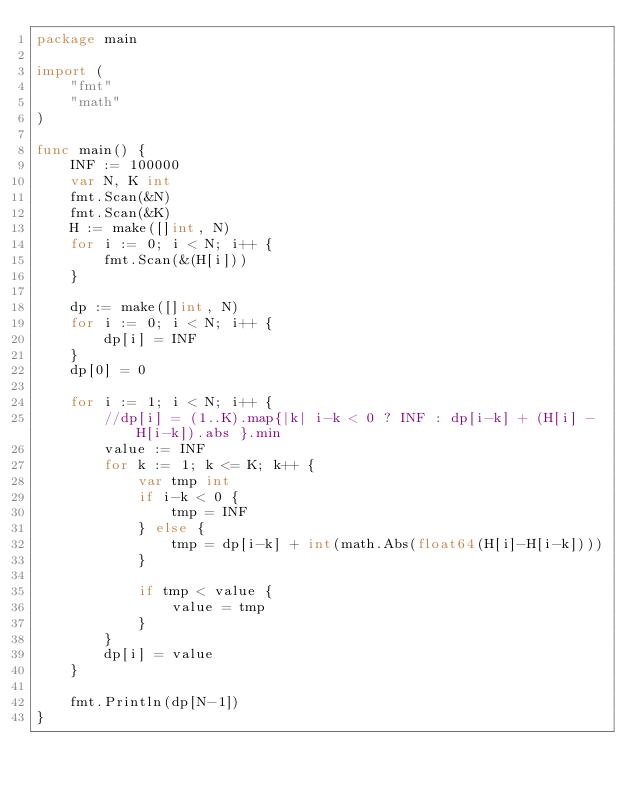<code> <loc_0><loc_0><loc_500><loc_500><_Go_>package main

import (
	"fmt"
	"math"
)

func main() {
	INF := 100000
	var N, K int
	fmt.Scan(&N)
	fmt.Scan(&K)
	H := make([]int, N)
	for i := 0; i < N; i++ {
		fmt.Scan(&(H[i]))
	}

	dp := make([]int, N)
	for i := 0; i < N; i++ {
		dp[i] = INF
	}
	dp[0] = 0

	for i := 1; i < N; i++ {
		//dp[i] = (1..K).map{|k| i-k < 0 ? INF : dp[i-k] + (H[i] - H[i-k]).abs }.min
		value := INF
		for k := 1; k <= K; k++ {
			var tmp int
			if i-k < 0 {
				tmp = INF
			} else {
				tmp = dp[i-k] + int(math.Abs(float64(H[i]-H[i-k])))
			}

			if tmp < value {
				value = tmp
			}
		}
		dp[i] = value
	}

	fmt.Println(dp[N-1])
}
</code> 